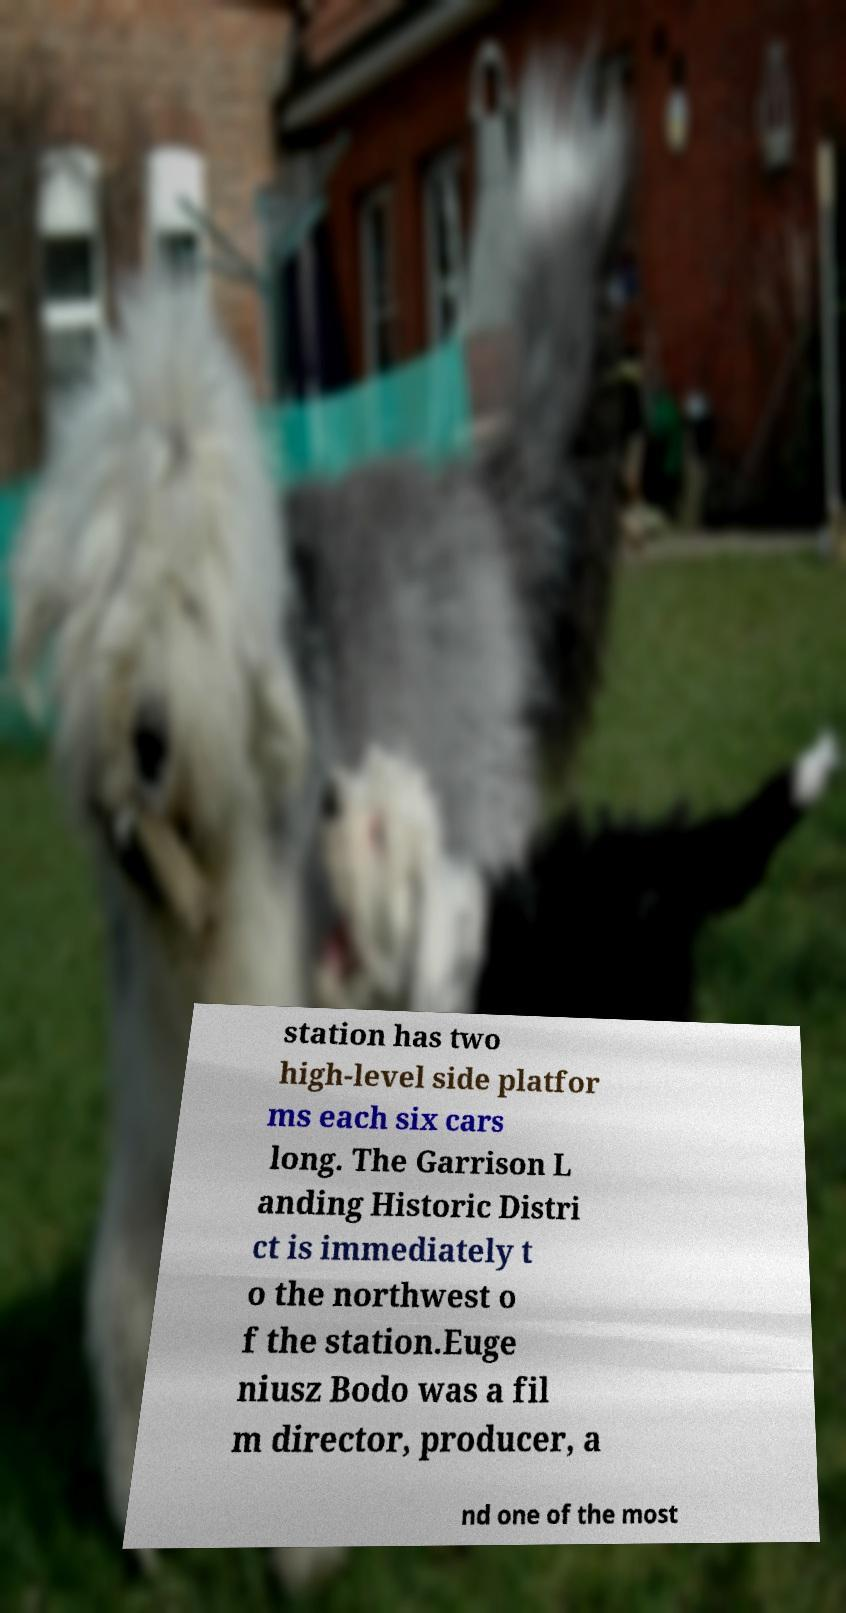Could you extract and type out the text from this image? station has two high-level side platfor ms each six cars long. The Garrison L anding Historic Distri ct is immediately t o the northwest o f the station.Euge niusz Bodo was a fil m director, producer, a nd one of the most 